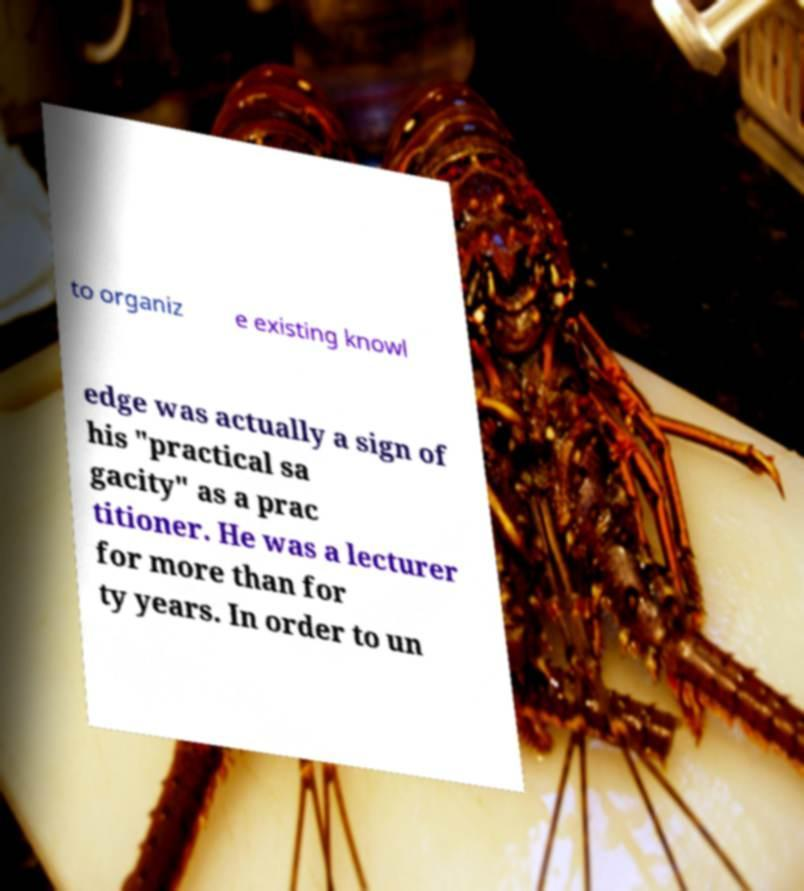What messages or text are displayed in this image? I need them in a readable, typed format. to organiz e existing knowl edge was actually a sign of his "practical sa gacity" as a prac titioner. He was a lecturer for more than for ty years. In order to un 